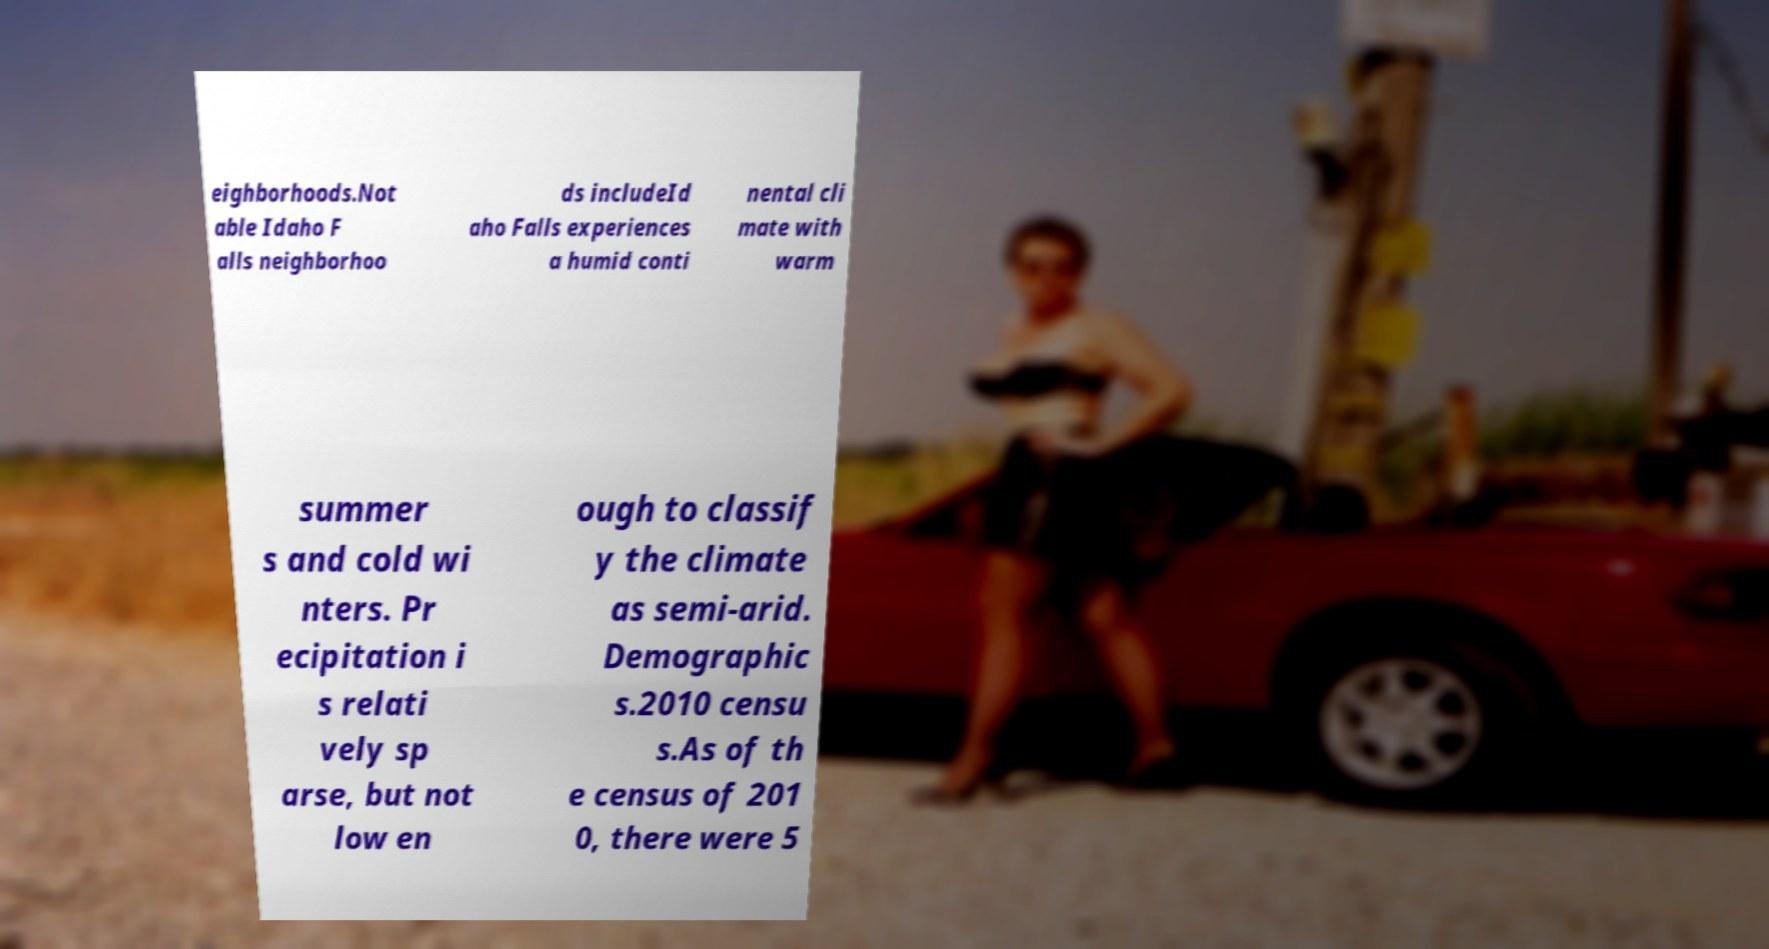Please read and relay the text visible in this image. What does it say? eighborhoods.Not able Idaho F alls neighborhoo ds includeId aho Falls experiences a humid conti nental cli mate with warm summer s and cold wi nters. Pr ecipitation i s relati vely sp arse, but not low en ough to classif y the climate as semi-arid. Demographic s.2010 censu s.As of th e census of 201 0, there were 5 